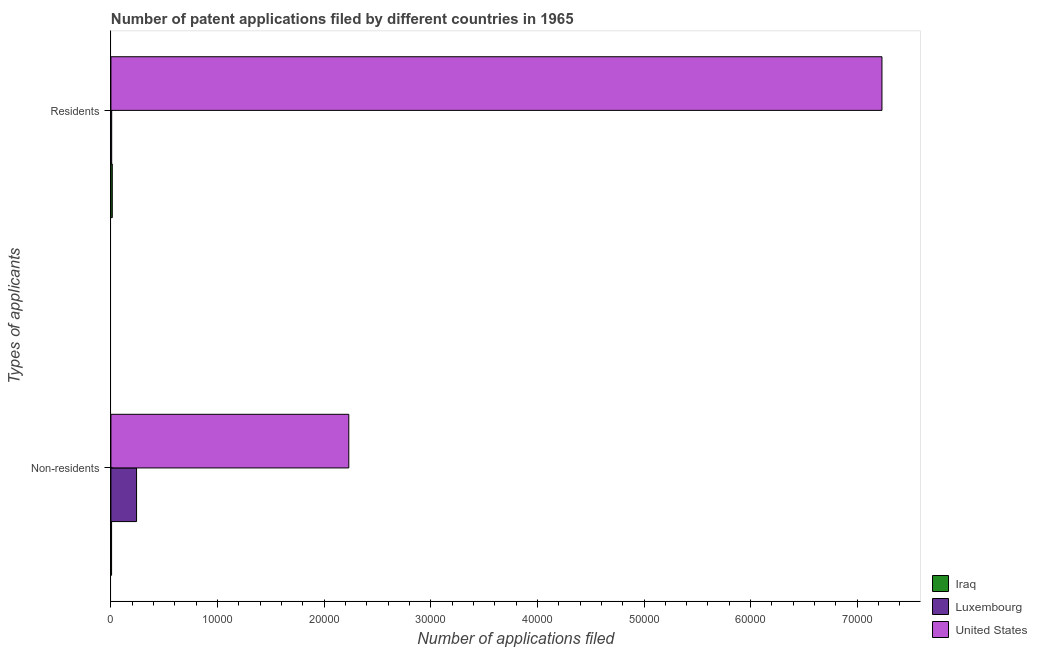How many different coloured bars are there?
Offer a very short reply. 3. How many bars are there on the 1st tick from the top?
Offer a terse response. 3. What is the label of the 1st group of bars from the top?
Offer a terse response. Residents. What is the number of patent applications by residents in United States?
Provide a succinct answer. 7.23e+04. Across all countries, what is the maximum number of patent applications by non residents?
Your answer should be compact. 2.23e+04. Across all countries, what is the minimum number of patent applications by non residents?
Your response must be concise. 62. In which country was the number of patent applications by non residents maximum?
Your response must be concise. United States. In which country was the number of patent applications by non residents minimum?
Your response must be concise. Iraq. What is the total number of patent applications by residents in the graph?
Provide a short and direct response. 7.25e+04. What is the difference between the number of patent applications by non residents in Iraq and that in Luxembourg?
Provide a succinct answer. -2344. What is the difference between the number of patent applications by residents in Luxembourg and the number of patent applications by non residents in Iraq?
Provide a succinct answer. 11. What is the average number of patent applications by residents per country?
Provide a short and direct response. 2.42e+04. What is the difference between the number of patent applications by non residents and number of patent applications by residents in United States?
Offer a terse response. -5.00e+04. What is the ratio of the number of patent applications by non residents in Luxembourg to that in Iraq?
Provide a succinct answer. 38.81. Is the number of patent applications by non residents in Luxembourg less than that in Iraq?
Your answer should be very brief. No. In how many countries, is the number of patent applications by residents greater than the average number of patent applications by residents taken over all countries?
Offer a very short reply. 1. What does the 2nd bar from the top in Residents represents?
Provide a succinct answer. Luxembourg. How many countries are there in the graph?
Provide a succinct answer. 3. Are the values on the major ticks of X-axis written in scientific E-notation?
Give a very brief answer. No. Does the graph contain any zero values?
Keep it short and to the point. No. Does the graph contain grids?
Your answer should be very brief. No. Where does the legend appear in the graph?
Make the answer very short. Bottom right. How many legend labels are there?
Ensure brevity in your answer.  3. How are the legend labels stacked?
Offer a terse response. Vertical. What is the title of the graph?
Give a very brief answer. Number of patent applications filed by different countries in 1965. Does "Tuvalu" appear as one of the legend labels in the graph?
Give a very brief answer. No. What is the label or title of the X-axis?
Provide a succinct answer. Number of applications filed. What is the label or title of the Y-axis?
Give a very brief answer. Types of applicants. What is the Number of applications filed of Iraq in Non-residents?
Your answer should be compact. 62. What is the Number of applications filed of Luxembourg in Non-residents?
Your answer should be compact. 2406. What is the Number of applications filed in United States in Non-residents?
Provide a short and direct response. 2.23e+04. What is the Number of applications filed of Iraq in Residents?
Provide a succinct answer. 129. What is the Number of applications filed of Luxembourg in Residents?
Your response must be concise. 73. What is the Number of applications filed in United States in Residents?
Your answer should be very brief. 7.23e+04. Across all Types of applicants, what is the maximum Number of applications filed in Iraq?
Ensure brevity in your answer.  129. Across all Types of applicants, what is the maximum Number of applications filed in Luxembourg?
Your answer should be compact. 2406. Across all Types of applicants, what is the maximum Number of applications filed of United States?
Give a very brief answer. 7.23e+04. Across all Types of applicants, what is the minimum Number of applications filed of United States?
Your answer should be compact. 2.23e+04. What is the total Number of applications filed in Iraq in the graph?
Offer a terse response. 191. What is the total Number of applications filed of Luxembourg in the graph?
Make the answer very short. 2479. What is the total Number of applications filed of United States in the graph?
Keep it short and to the point. 9.46e+04. What is the difference between the Number of applications filed in Iraq in Non-residents and that in Residents?
Your answer should be very brief. -67. What is the difference between the Number of applications filed in Luxembourg in Non-residents and that in Residents?
Your answer should be very brief. 2333. What is the difference between the Number of applications filed in United States in Non-residents and that in Residents?
Your response must be concise. -5.00e+04. What is the difference between the Number of applications filed in Iraq in Non-residents and the Number of applications filed in United States in Residents?
Keep it short and to the point. -7.23e+04. What is the difference between the Number of applications filed of Luxembourg in Non-residents and the Number of applications filed of United States in Residents?
Ensure brevity in your answer.  -6.99e+04. What is the average Number of applications filed in Iraq per Types of applicants?
Ensure brevity in your answer.  95.5. What is the average Number of applications filed in Luxembourg per Types of applicants?
Make the answer very short. 1239.5. What is the average Number of applications filed of United States per Types of applicants?
Your answer should be compact. 4.73e+04. What is the difference between the Number of applications filed of Iraq and Number of applications filed of Luxembourg in Non-residents?
Your answer should be very brief. -2344. What is the difference between the Number of applications filed of Iraq and Number of applications filed of United States in Non-residents?
Keep it short and to the point. -2.22e+04. What is the difference between the Number of applications filed in Luxembourg and Number of applications filed in United States in Non-residents?
Ensure brevity in your answer.  -1.99e+04. What is the difference between the Number of applications filed of Iraq and Number of applications filed of Luxembourg in Residents?
Provide a succinct answer. 56. What is the difference between the Number of applications filed in Iraq and Number of applications filed in United States in Residents?
Your answer should be compact. -7.22e+04. What is the difference between the Number of applications filed in Luxembourg and Number of applications filed in United States in Residents?
Your answer should be compact. -7.22e+04. What is the ratio of the Number of applications filed of Iraq in Non-residents to that in Residents?
Provide a succinct answer. 0.48. What is the ratio of the Number of applications filed in Luxembourg in Non-residents to that in Residents?
Offer a very short reply. 32.96. What is the ratio of the Number of applications filed of United States in Non-residents to that in Residents?
Give a very brief answer. 0.31. What is the difference between the highest and the second highest Number of applications filed of Iraq?
Offer a very short reply. 67. What is the difference between the highest and the second highest Number of applications filed in Luxembourg?
Ensure brevity in your answer.  2333. What is the difference between the highest and the second highest Number of applications filed in United States?
Keep it short and to the point. 5.00e+04. What is the difference between the highest and the lowest Number of applications filed of Iraq?
Ensure brevity in your answer.  67. What is the difference between the highest and the lowest Number of applications filed in Luxembourg?
Ensure brevity in your answer.  2333. What is the difference between the highest and the lowest Number of applications filed in United States?
Your answer should be compact. 5.00e+04. 